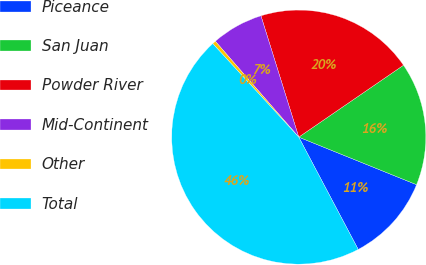<chart> <loc_0><loc_0><loc_500><loc_500><pie_chart><fcel>Piceance<fcel>San Juan<fcel>Powder River<fcel>Mid-Continent<fcel>Other<fcel>Total<nl><fcel>11.14%<fcel>15.68%<fcel>20.23%<fcel>6.59%<fcel>0.44%<fcel>45.91%<nl></chart> 